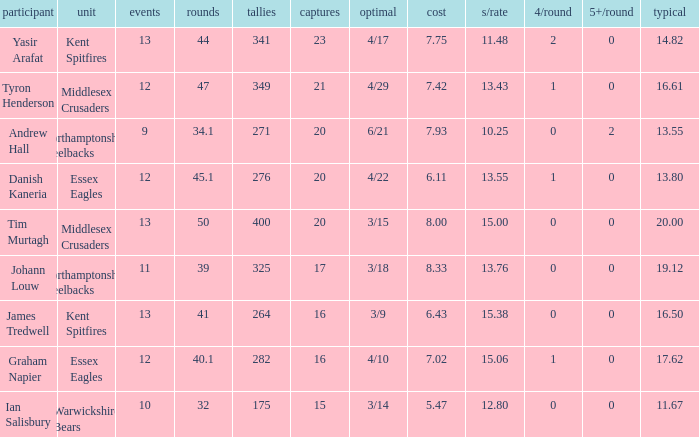Name the most wickets for best is 4/22 20.0. 